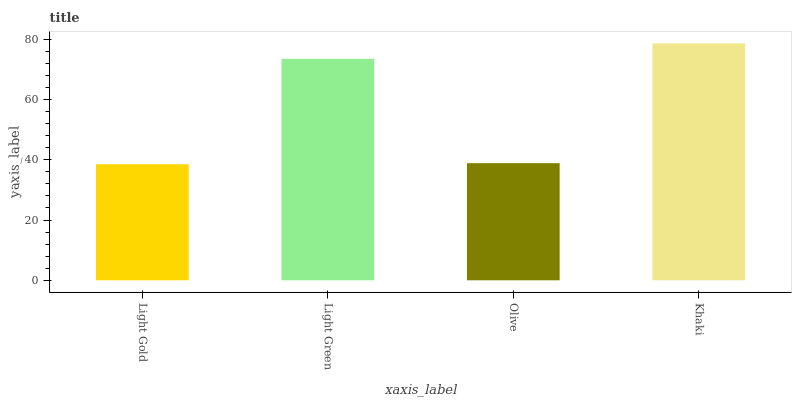Is Light Gold the minimum?
Answer yes or no. Yes. Is Khaki the maximum?
Answer yes or no. Yes. Is Light Green the minimum?
Answer yes or no. No. Is Light Green the maximum?
Answer yes or no. No. Is Light Green greater than Light Gold?
Answer yes or no. Yes. Is Light Gold less than Light Green?
Answer yes or no. Yes. Is Light Gold greater than Light Green?
Answer yes or no. No. Is Light Green less than Light Gold?
Answer yes or no. No. Is Light Green the high median?
Answer yes or no. Yes. Is Olive the low median?
Answer yes or no. Yes. Is Khaki the high median?
Answer yes or no. No. Is Khaki the low median?
Answer yes or no. No. 